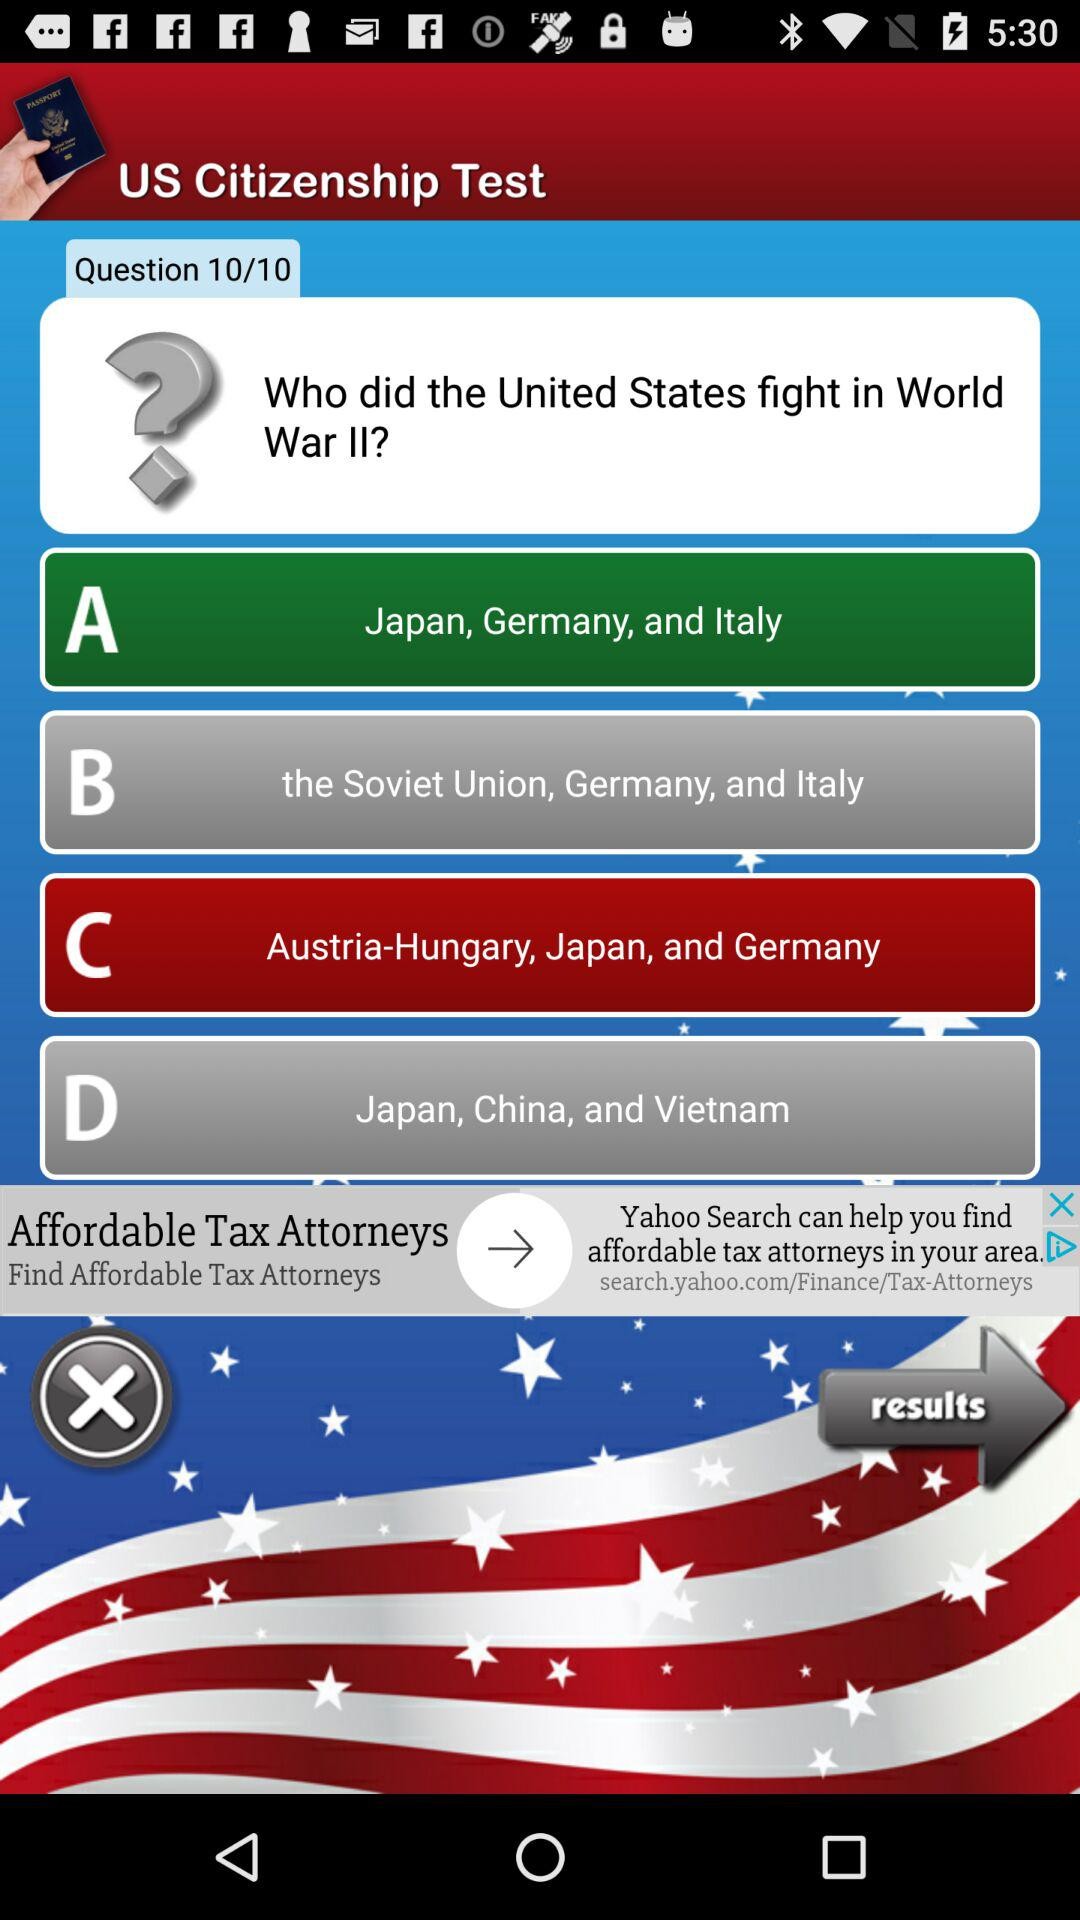At which question is the person? The person is at the 10th question. 